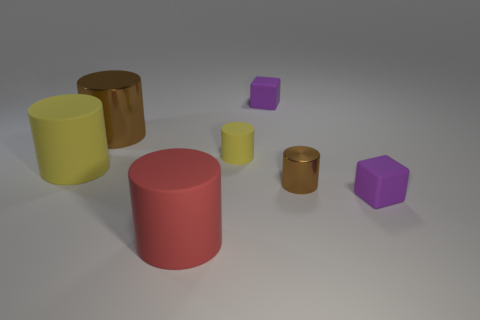What number of other things are there of the same shape as the red matte object?
Your response must be concise. 4. There is a matte cylinder that is behind the big yellow object; is its color the same as the large thing behind the large yellow rubber cylinder?
Provide a succinct answer. No. How many small objects are either yellow cylinders or purple objects?
Make the answer very short. 3. What is the size of the red rubber object that is the same shape as the tiny brown object?
Make the answer very short. Large. Is there anything else that is the same size as the red thing?
Your answer should be very brief. Yes. There is a small cube right of the brown cylinder in front of the large yellow cylinder; what is its material?
Provide a short and direct response. Rubber. How many metal things are tiny yellow cylinders or cyan cubes?
Provide a succinct answer. 0. There is another tiny thing that is the same shape as the small brown metal object; what is its color?
Provide a short and direct response. Yellow. What number of big metal things have the same color as the large metallic cylinder?
Keep it short and to the point. 0. There is a brown object that is in front of the big metallic object; are there any matte cylinders that are to the left of it?
Give a very brief answer. Yes. 